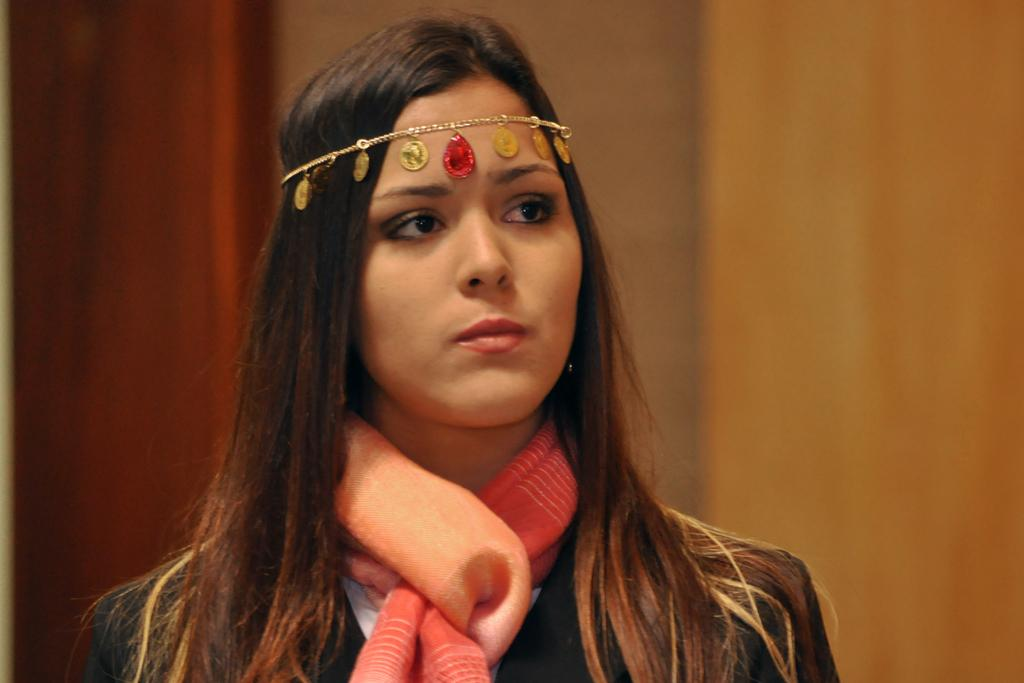What is the main subject of the image? The main subject of the image is a woman. What is the woman doing in the image? The woman is staring at something. What type of button is the woman wearing in the image? There is no button visible on the woman in the image. What message of peace is the woman conveying in the image? The image does not convey any message of peace, as it only shows a woman staring at something. 